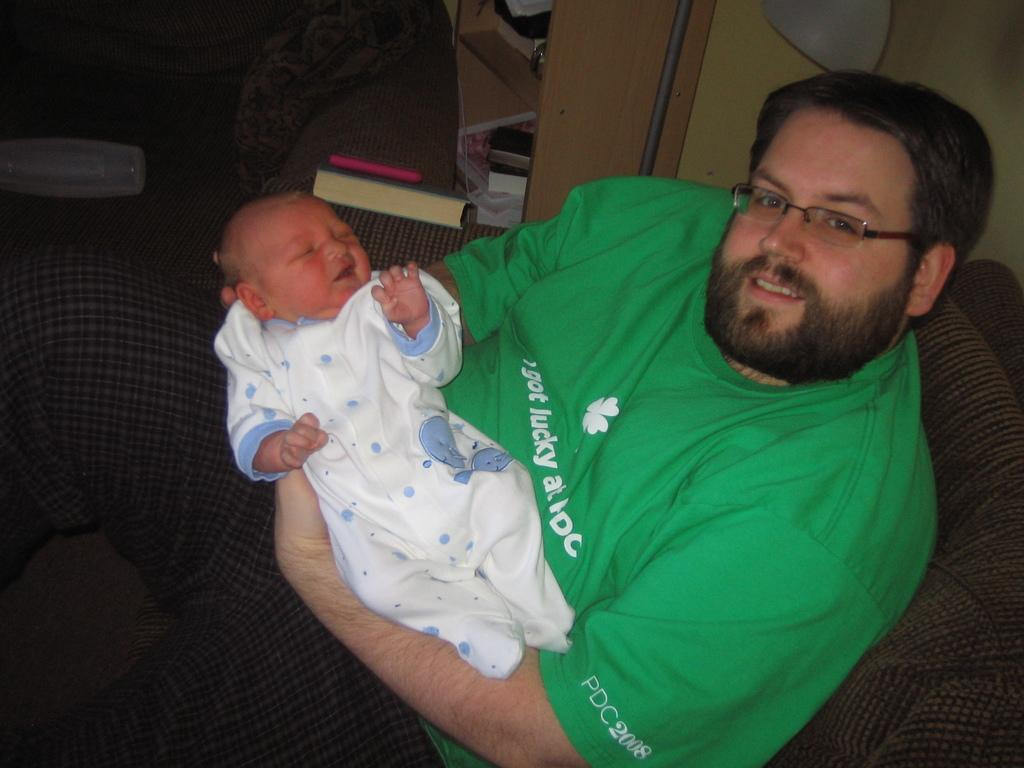<image>
Describe the image concisely. A man wearing an "I got lucky shirt" holds a baby. 